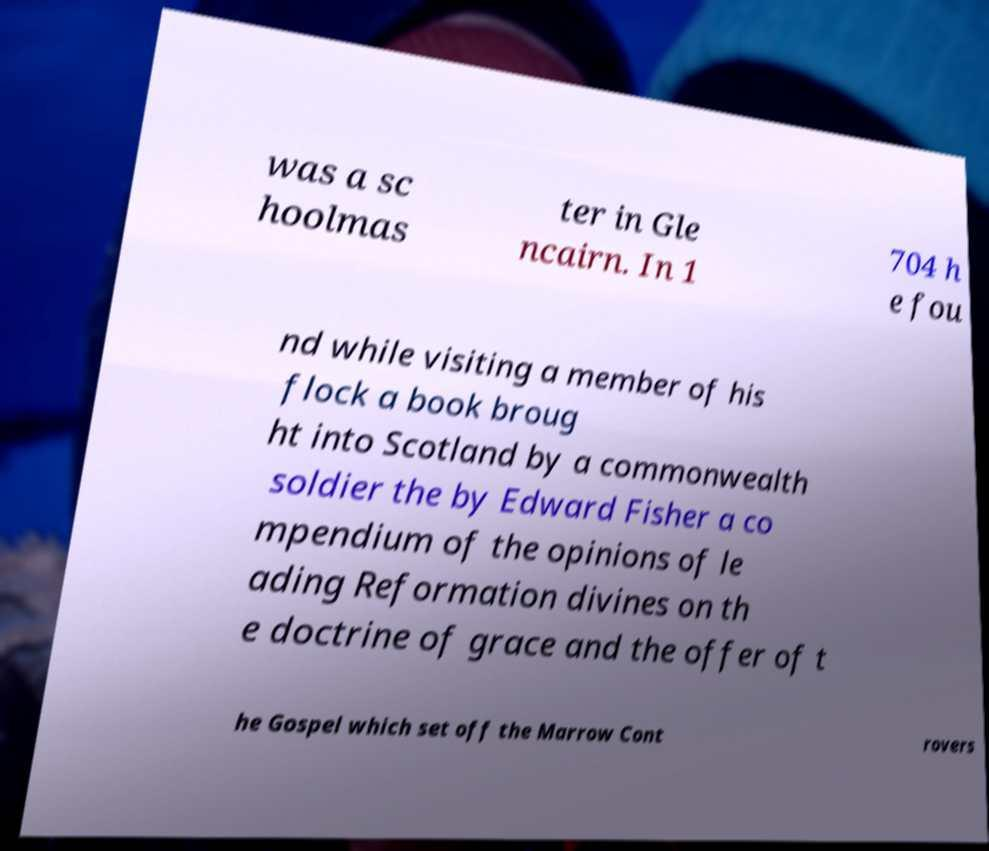Please read and relay the text visible in this image. What does it say? was a sc hoolmas ter in Gle ncairn. In 1 704 h e fou nd while visiting a member of his flock a book broug ht into Scotland by a commonwealth soldier the by Edward Fisher a co mpendium of the opinions of le ading Reformation divines on th e doctrine of grace and the offer of t he Gospel which set off the Marrow Cont rovers 